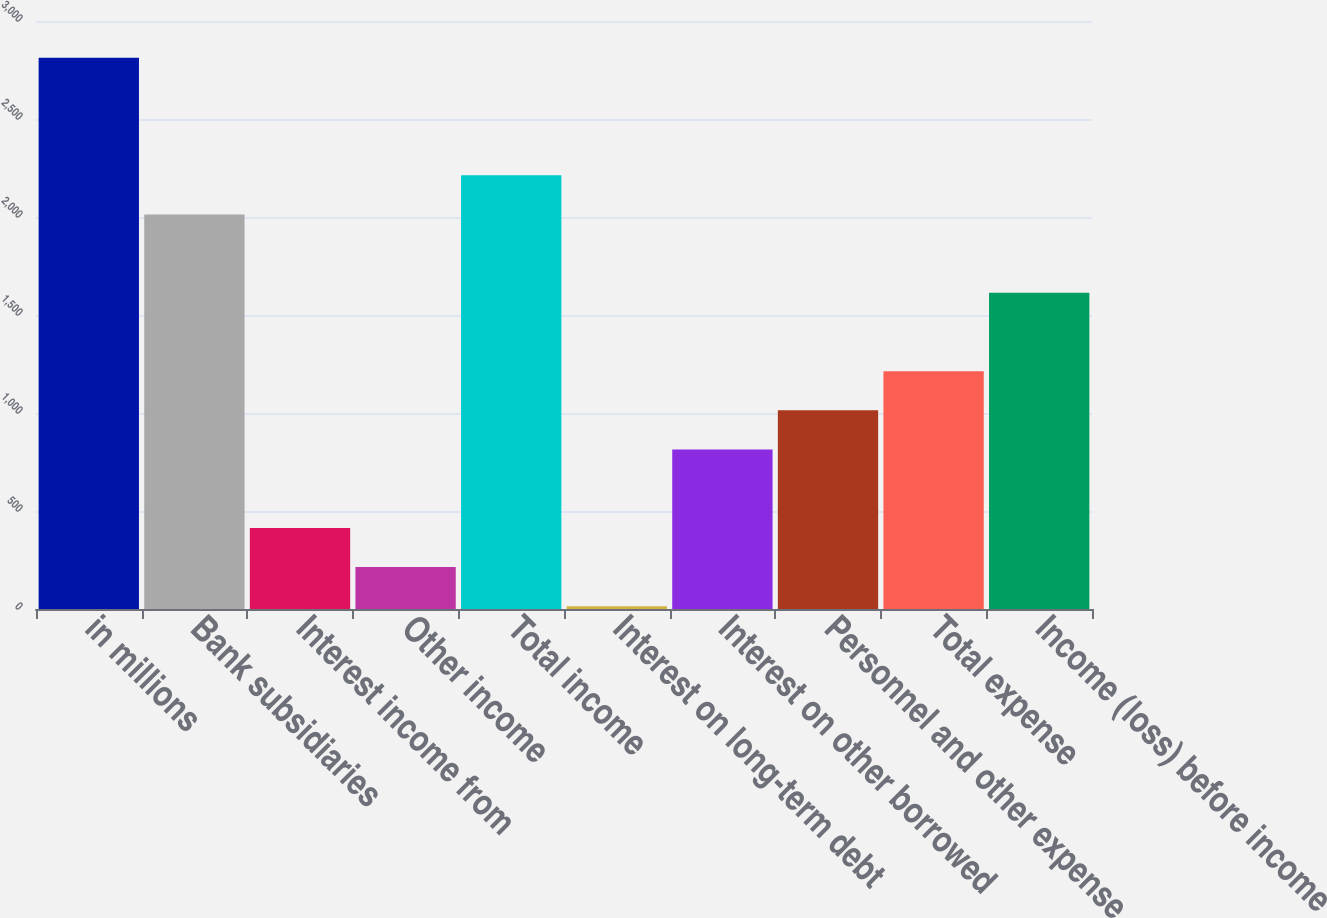Convert chart. <chart><loc_0><loc_0><loc_500><loc_500><bar_chart><fcel>in millions<fcel>Bank subsidiaries<fcel>Interest income from<fcel>Other income<fcel>Total income<fcel>Interest on long-term debt<fcel>Interest on other borrowed<fcel>Personnel and other expense<fcel>Total expense<fcel>Income (loss) before income<nl><fcel>2812.6<fcel>2013<fcel>413.8<fcel>213.9<fcel>2212.9<fcel>14<fcel>813.6<fcel>1013.5<fcel>1213.4<fcel>1613.2<nl></chart> 